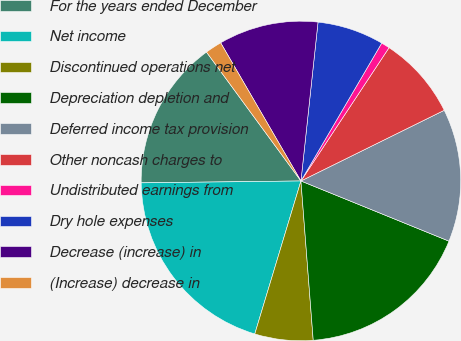Convert chart. <chart><loc_0><loc_0><loc_500><loc_500><pie_chart><fcel>For the years ended December<fcel>Net income<fcel>Discontinued operations net<fcel>Depreciation depletion and<fcel>Deferred income tax provision<fcel>Other noncash charges to<fcel>Undistributed earnings from<fcel>Dry hole expenses<fcel>Decrease (increase) in<fcel>(Increase) decrease in<nl><fcel>15.12%<fcel>20.15%<fcel>5.89%<fcel>17.63%<fcel>13.44%<fcel>8.41%<fcel>0.86%<fcel>6.73%<fcel>10.08%<fcel>1.69%<nl></chart> 